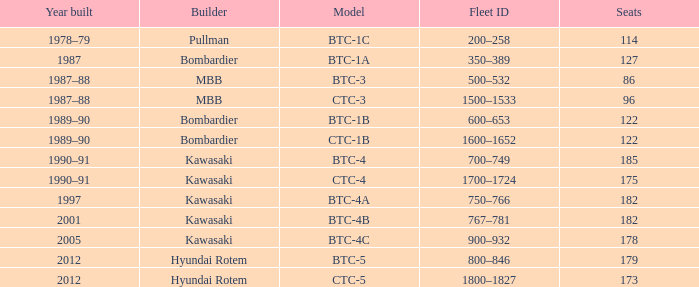Which model features 175 seating capacity? CTC-4. 